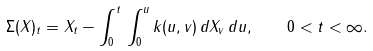<formula> <loc_0><loc_0><loc_500><loc_500>\Sigma ( X ) _ { t } = X _ { t } - \int _ { 0 } ^ { t } \, \int _ { 0 } ^ { u } k ( u , v ) \, d X _ { v } \, d u , \quad 0 < t < \infty .</formula> 